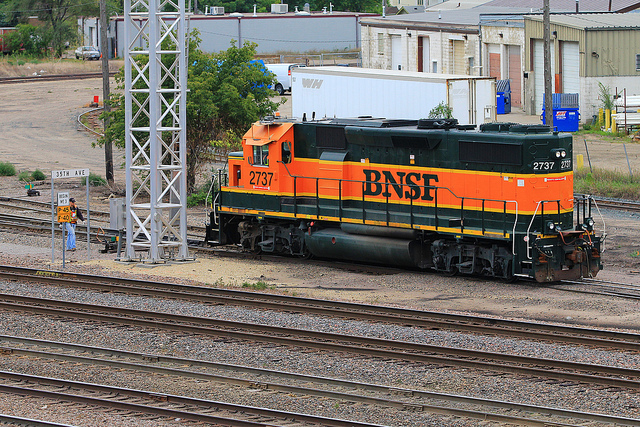<image>What design is on the side of the train? I don't know the exact design on the side of the train. However, it can be a 'bnsf' logo or an 'orange stripe'. What design is on the side of the train? I don't know what design is on the side of the train. It can be seen 'bnsf', 'stripe', 'orange stripe', 'bnsf logo', or 'letters'. 